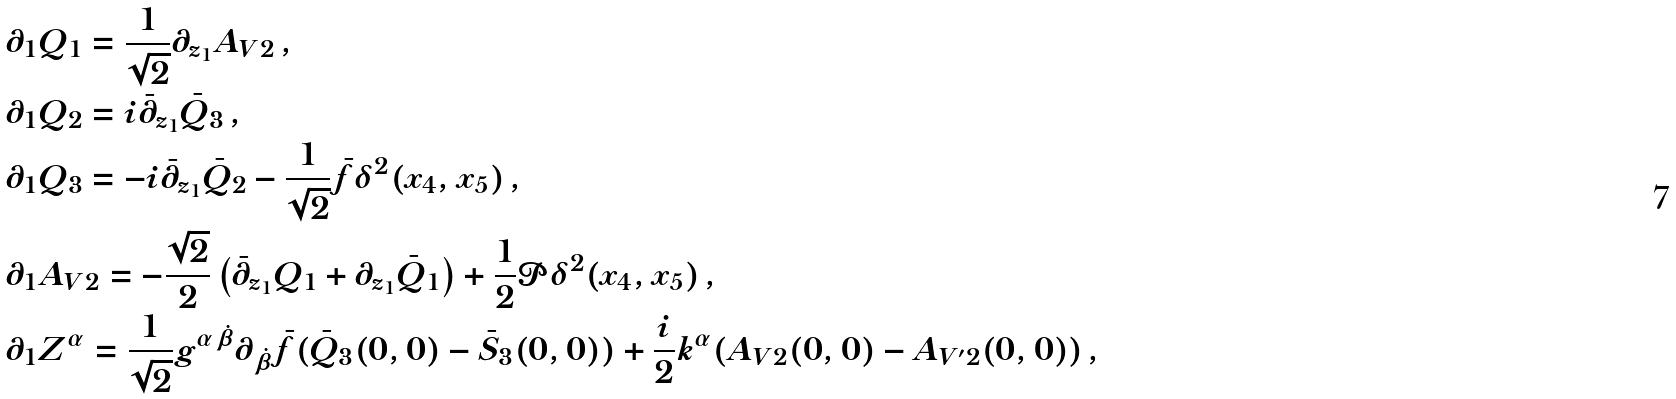<formula> <loc_0><loc_0><loc_500><loc_500>& \partial _ { 1 } Q _ { 1 } = \frac { 1 } { \sqrt { 2 } } \partial _ { z _ { 1 } } A _ { V 2 } \, , \\ & \partial _ { 1 } Q _ { 2 } = i \bar { \partial } _ { z _ { 1 } } \bar { Q } _ { 3 } \, , \\ & \partial _ { 1 } Q _ { 3 } = - i \bar { \partial } _ { z _ { 1 } } \bar { Q } _ { 2 } - \frac { 1 } { \sqrt { 2 } } \bar { f } \delta ^ { 2 } ( x _ { 4 } , x _ { 5 } ) \, , \\ & \partial _ { 1 } A _ { V 2 } = - \frac { \sqrt { 2 } } { 2 } \left ( \bar { \partial } _ { z _ { 1 } } Q _ { 1 } + \partial _ { z _ { 1 } } \bar { Q } _ { 1 } \right ) + \frac { 1 } { 2 } \mathcal { P } \delta ^ { 2 } ( x _ { 4 } , x _ { 5 } ) \, , \\ & \partial _ { 1 } Z ^ { \alpha } = \frac { 1 } { \sqrt { 2 } } g ^ { \alpha \dot { \beta } } \partial _ { \dot { \beta } } \bar { f } ( \bar { Q } _ { 3 } ( 0 , 0 ) - \bar { S } _ { 3 } ( 0 , 0 ) ) + \frac { i } { 2 } k ^ { \alpha } ( A _ { V 2 } ( 0 , 0 ) - A _ { V ^ { \prime } 2 } ( 0 , 0 ) ) \, ,</formula> 